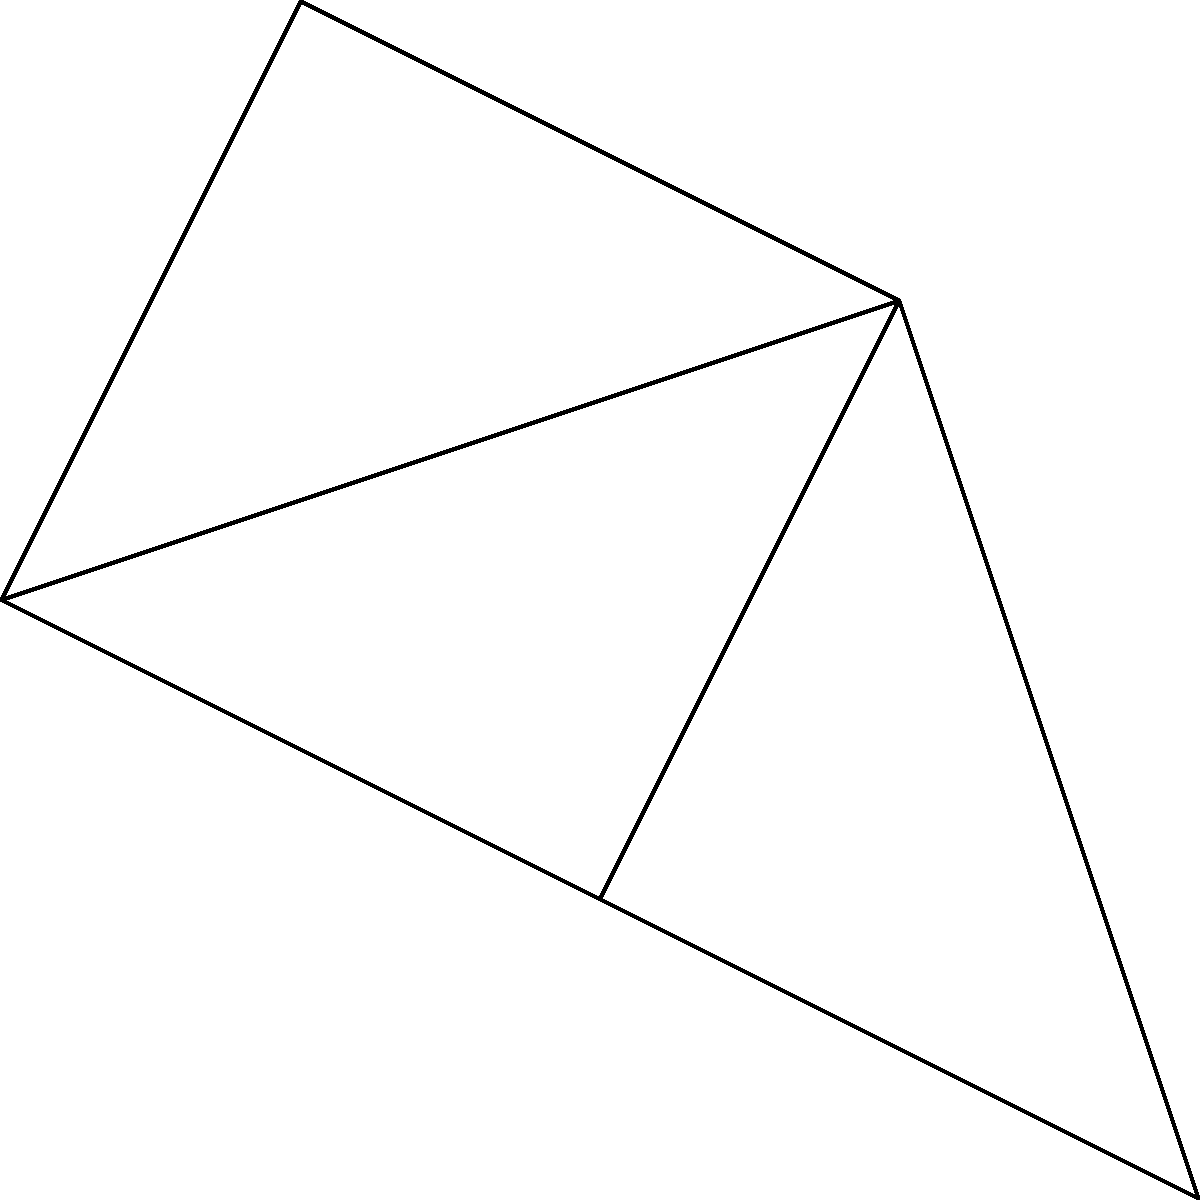In this simplified road network of South Holland, how many different routes can a driver take from vertex $v_1$ to vertex $v_5$ without revisiting any intersection? To solve this problem, we need to count all possible paths from $v_1$ to $v_5$ without repeating any vertex. Let's break it down step-by-step:

1. Start at $v_1$. From here, we have three options: $v_2$, $v_3$, or $v_4$.

2. If we go through $v_2$:
   - The only path is $v_1 \to v_2 \to v_3 \to v_5$
   - This gives us 1 route

3. If we go through $v_3$:
   - We can go directly to $v_5$: $v_1 \to v_3 \to v_5$
   - Or we can go through $v_4$: $v_1 \to v_3 \to v_4 \to v_5$
   - This gives us 2 routes

4. If we go through $v_4$:
   - The only path is $v_1 \to v_4 \to v_5$
   - This gives us 1 route

5. Sum up all possible routes:
   $1 + 2 + 1 = 4$ routes in total

Therefore, there are 4 different routes a driver can take from $v_1$ to $v_5$ without revisiting any intersection.
Answer: 4 routes 